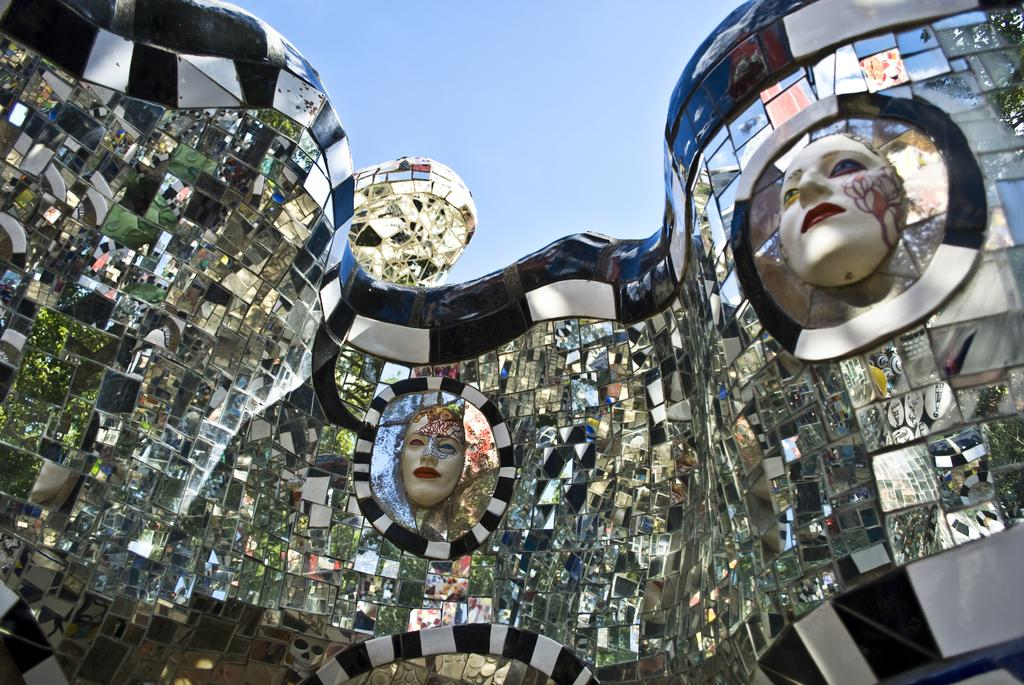What type of glasses are featured in the image? There are 3D glasses in the image. How are the 3D glasses positioned in the image? The 3D glasses are attached together. What other objects can be seen in the image? There are statues of human faces in the image. What is visible at the top of the image? The sky is visible at the top of the image. How would you describe the sky in the image? The sky appears clear in the image. How many snails are crawling on the 3D glasses in the image? There are no snails present in the image; it only features 3D glasses and statues of human faces. 